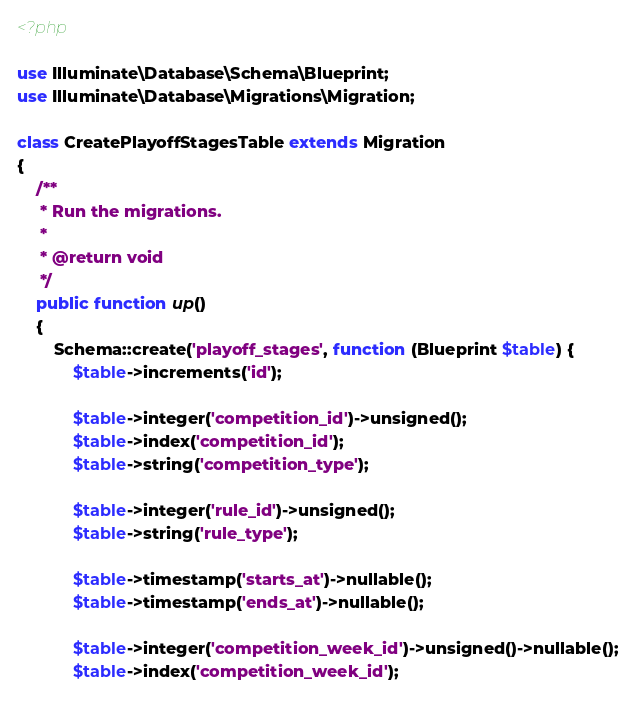Convert code to text. <code><loc_0><loc_0><loc_500><loc_500><_PHP_><?php

use Illuminate\Database\Schema\Blueprint;
use Illuminate\Database\Migrations\Migration;

class CreatePlayoffStagesTable extends Migration
{
    /**
     * Run the migrations.
     *
     * @return void
     */
    public function up()
    {
        Schema::create('playoff_stages', function (Blueprint $table) {
            $table->increments('id');

            $table->integer('competition_id')->unsigned();
            $table->index('competition_id');
            $table->string('competition_type');

            $table->integer('rule_id')->unsigned();
            $table->string('rule_type');

            $table->timestamp('starts_at')->nullable();
            $table->timestamp('ends_at')->nullable();

            $table->integer('competition_week_id')->unsigned()->nullable();
            $table->index('competition_week_id');</code> 